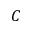<formula> <loc_0><loc_0><loc_500><loc_500>C</formula> 